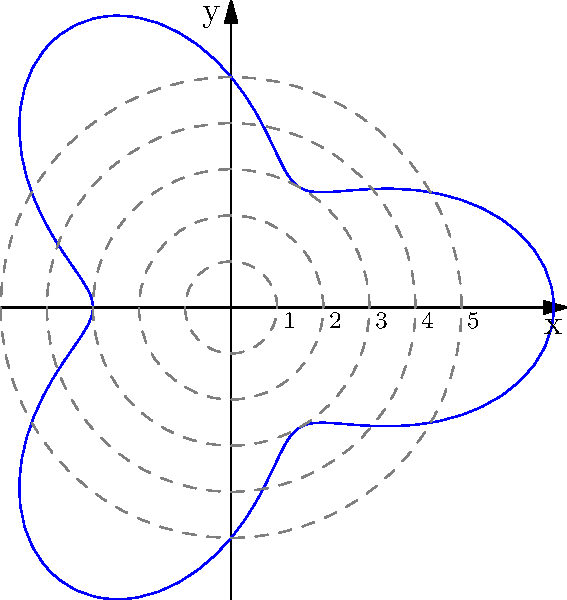The polar graph represents the coverage area of a mobile health clinic in a rural region. The radius $r$ is given by the function $r(\theta) = 5 + 2\cos(3\theta)$, where $r$ is in kilometers and $\theta$ is in radians. What is the maximum radius of coverage, and at which angle(s) does it occur? To find the maximum radius and the corresponding angle(s), we need to follow these steps:

1) The maximum radius occurs when $\cos(3\theta)$ is at its maximum value, which is 1.

2) When $\cos(3\theta) = 1$, the radius function becomes:
   $r(\theta) = 5 + 2(1) = 7$ km

3) To find the angle(s) where this occurs, we need to solve:
   $\cos(3\theta) = 1$

4) The general solution for this equation is:
   $3\theta = 2\pi n$, where $n$ is an integer

5) Solving for $\theta$:
   $\theta = \frac{2\pi n}{3}$

6) In the interval $[0, 2\pi]$, this occurs three times:
   When $n = 0$: $\theta = 0$
   When $n = 1$: $\theta = \frac{2\pi}{3}$ (or 120°)
   When $n = 2$: $\theta = \frac{4\pi}{3}$ (or 240°)

Therefore, the maximum radius is 7 km, occurring at angles 0°, 120°, and 240°.
Answer: 7 km at 0°, 120°, and 240° 